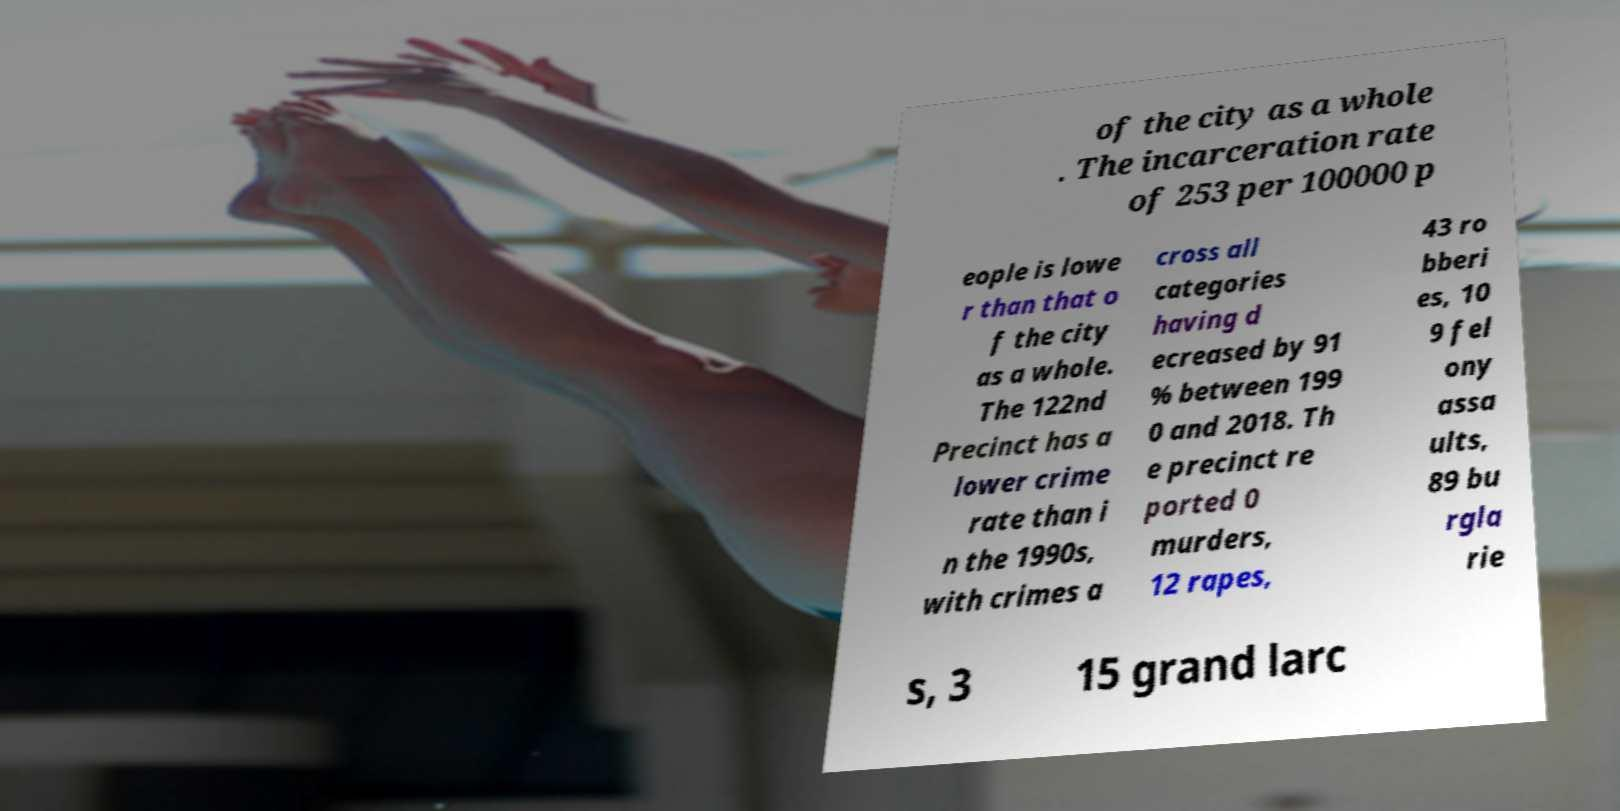There's text embedded in this image that I need extracted. Can you transcribe it verbatim? of the city as a whole . The incarceration rate of 253 per 100000 p eople is lowe r than that o f the city as a whole. The 122nd Precinct has a lower crime rate than i n the 1990s, with crimes a cross all categories having d ecreased by 91 % between 199 0 and 2018. Th e precinct re ported 0 murders, 12 rapes, 43 ro bberi es, 10 9 fel ony assa ults, 89 bu rgla rie s, 3 15 grand larc 